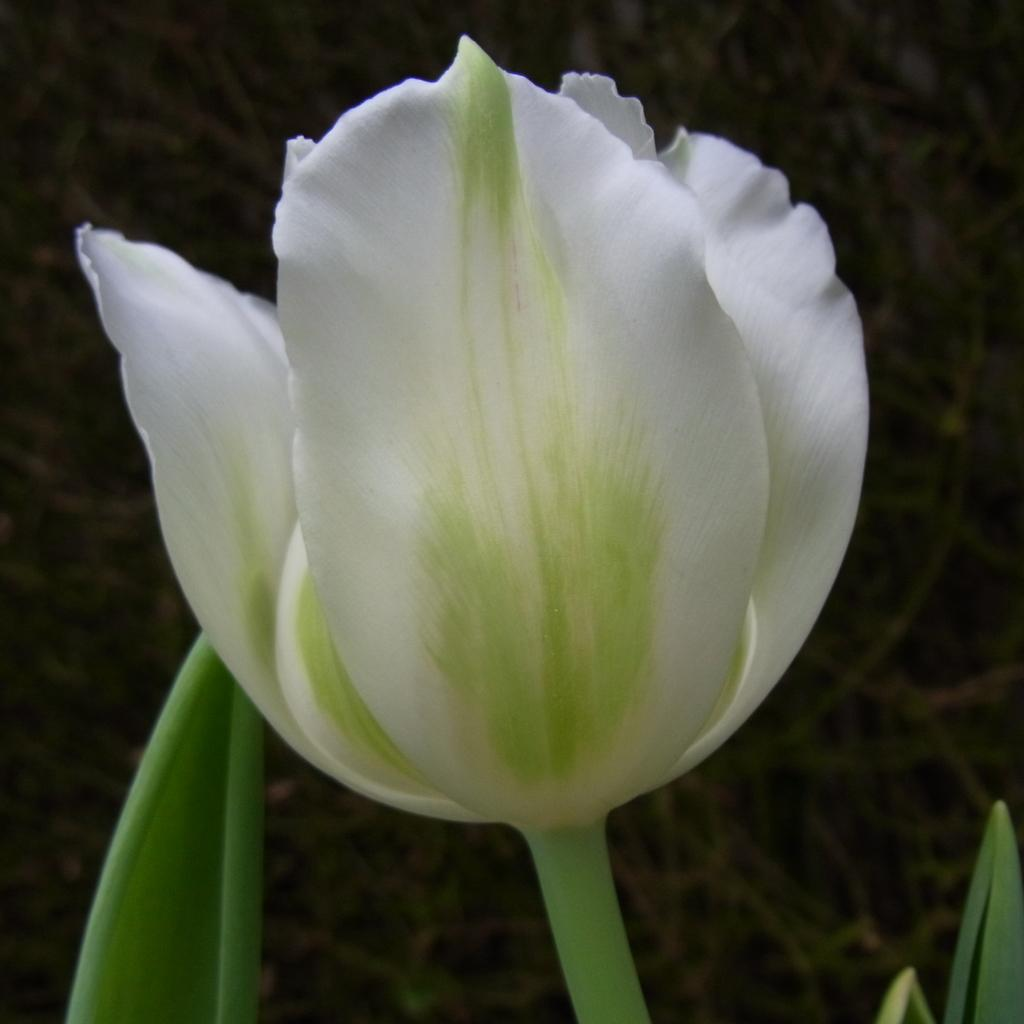What is the main subject of the image? There is a flower in the image. What parts of the flower can be seen in the image? There is a stem and leaves visible in the image. How would you describe the background of the image? The background of the image is blurred. How many jellyfish can be seen swimming in the image? There are no jellyfish present in the image; it features a flower with a stem and leaves. Is there a tray holding the flower in the image? There is no tray visible in the image. 